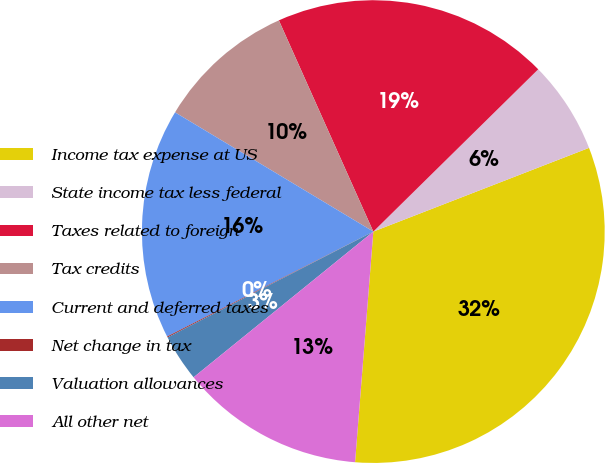Convert chart. <chart><loc_0><loc_0><loc_500><loc_500><pie_chart><fcel>Income tax expense at US<fcel>State income tax less federal<fcel>Taxes related to foreign<fcel>Tax credits<fcel>Current and deferred taxes<fcel>Net change in tax<fcel>Valuation allowances<fcel>All other net<nl><fcel>32.15%<fcel>6.48%<fcel>19.32%<fcel>9.69%<fcel>16.11%<fcel>0.07%<fcel>3.28%<fcel>12.9%<nl></chart> 